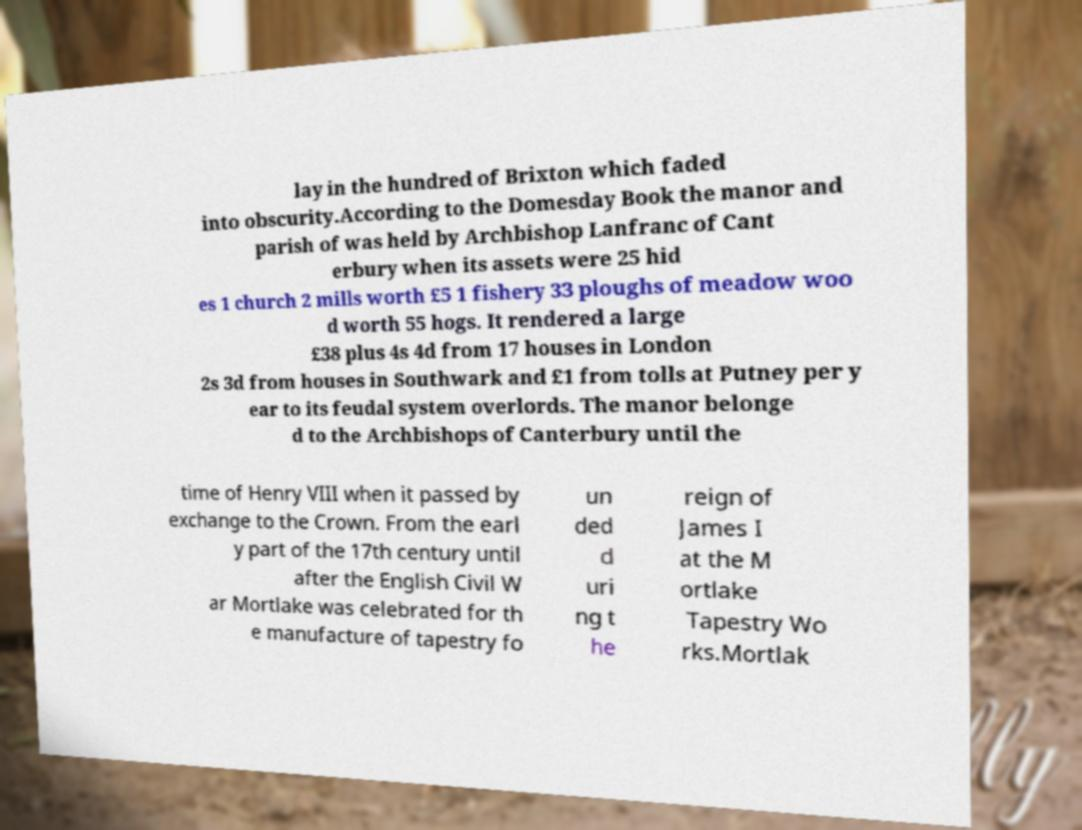Please read and relay the text visible in this image. What does it say? lay in the hundred of Brixton which faded into obscurity.According to the Domesday Book the manor and parish of was held by Archbishop Lanfranc of Cant erbury when its assets were 25 hid es 1 church 2 mills worth £5 1 fishery 33 ploughs of meadow woo d worth 55 hogs. It rendered a large £38 plus 4s 4d from 17 houses in London 2s 3d from houses in Southwark and £1 from tolls at Putney per y ear to its feudal system overlords. The manor belonge d to the Archbishops of Canterbury until the time of Henry VIII when it passed by exchange to the Crown. From the earl y part of the 17th century until after the English Civil W ar Mortlake was celebrated for th e manufacture of tapestry fo un ded d uri ng t he reign of James I at the M ortlake Tapestry Wo rks.Mortlak 